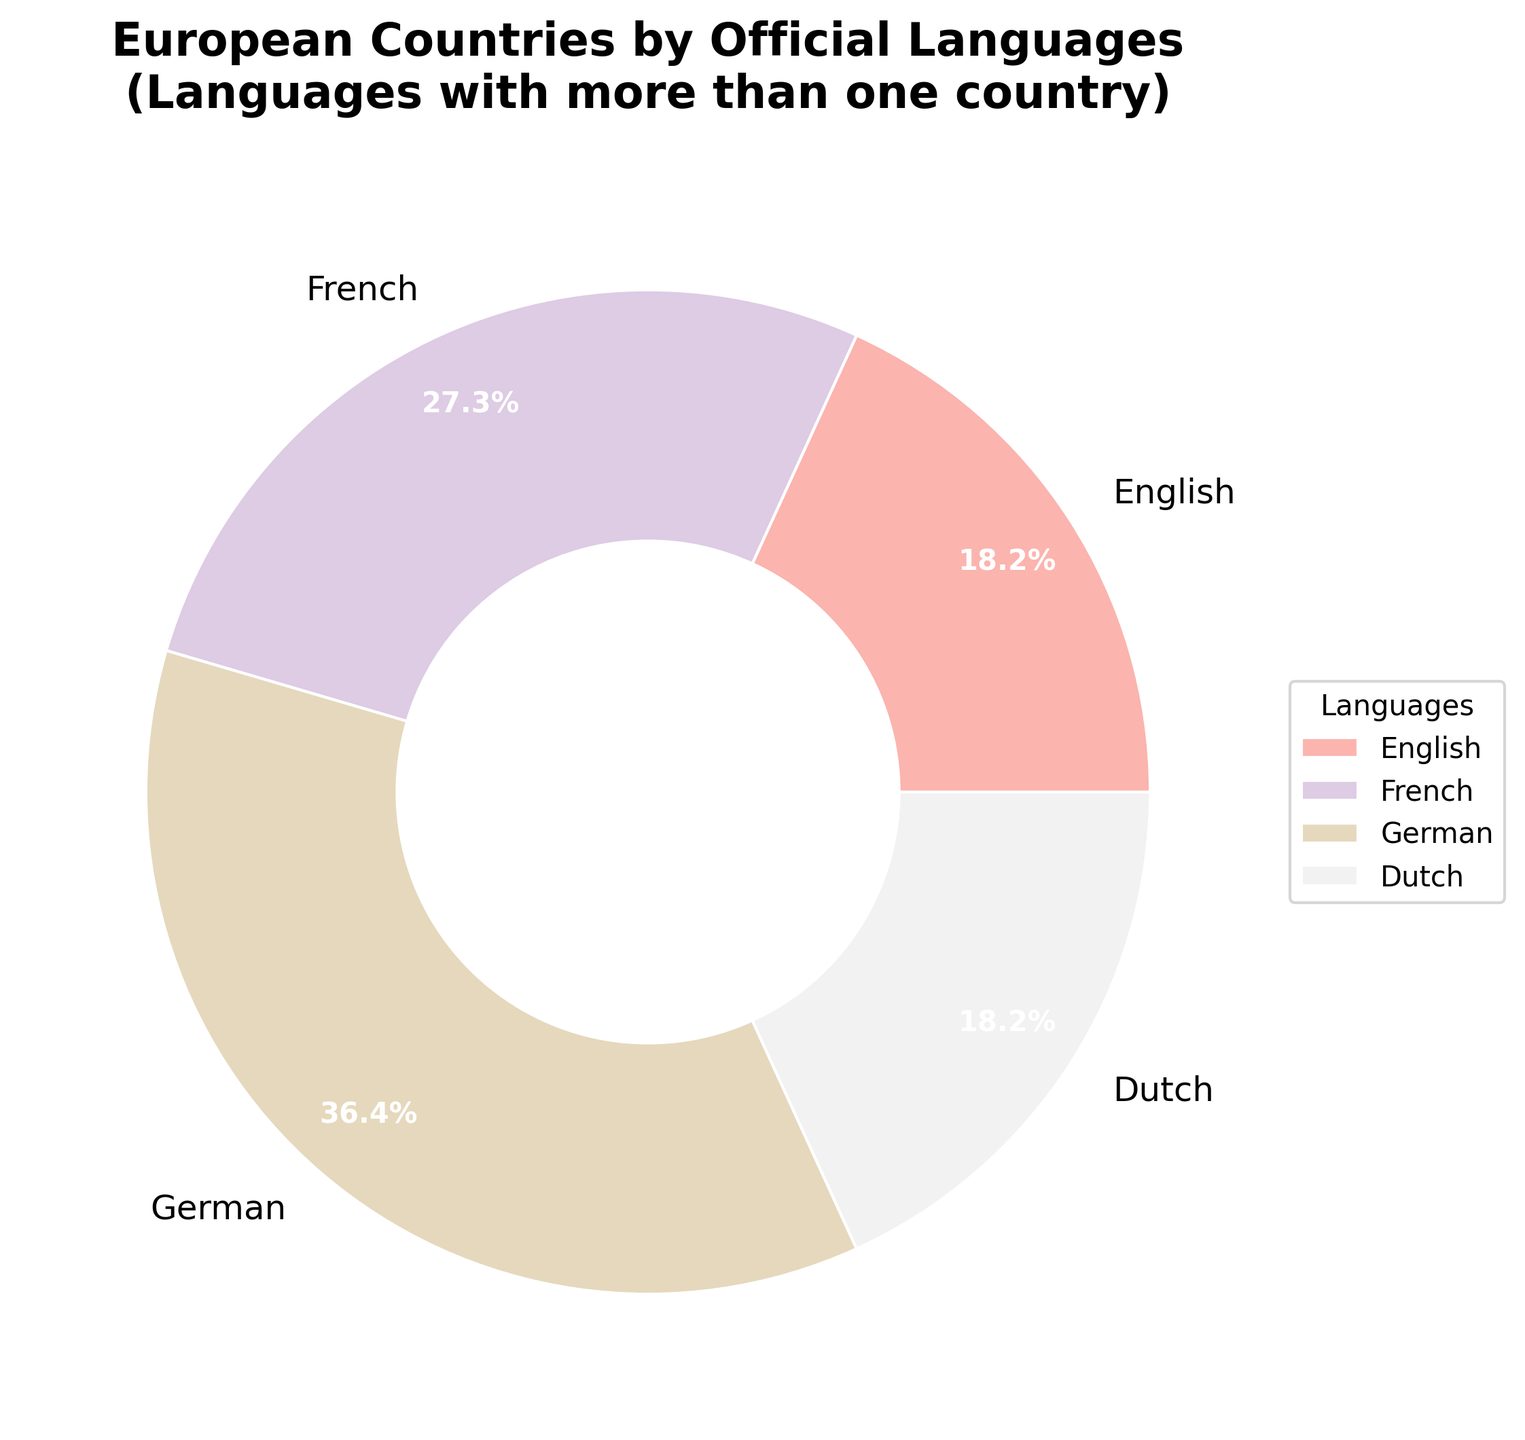Which language is the official language of the most countries? From the pie chart, German appears to account for the highest percentage. German is associated with 4 countries, which is more than any other language in the chart.
Answer: German How many languages are shared by more than one country? The pie chart displays sections with labels and percentages. Adding the sections that have more than one country, we see English (2), French (3), German (4), and Dutch (2), resulting in 4 languages.
Answer: 4 What percentage of the countries listed use French as an official language? From the pie chart, French is represented as 23.1%. This value directly indicates the percentage of countries that use French as an official language.
Answer: 23.1% Which languages tie for the fewest number of countries using them? The chart only includes languages shared by more than one country, but based on the data, other languages like Italian, Spanish, etc., which are used by only 1 country each, would not appear here.
Answer: Italian, Spanish, etc If you were to combine the percentages of countries that speak English and French, what would be the total percentage? From the pie chart, English accounts for 15.4% and French accounts for 23.1%. Adding these yields 15.4% + 23.1% = 38.5%.
Answer: 38.5% Is Dutch spoken in more or fewer countries than English? According to the pie chart, Dutch is spoken in fewer countries than English. Dutch is represented with 15.4%, while English also has 15.4%, but the number of countries for Dutch and English are both 2 each.
Answer: Fewer (equal number in this specific subset) Which section is represented with the color towards the bottom of the pie chart? The largest bottom wedge of the pie chart is colored in a particular shade and labeled German, indicating the section towards the bottom.
Answer: German Compare the combined total percentage of countries speaking German and French to that of the countries speaking English and Dutch. German is 30.8% and French is 23.1%, adding up to 53.9%. English is 15.4% and Dutch is also 15.4%. Adding these two gives 30.8%. Thus, 53.9% (German + French) is greater than 30.8% (English + Dutch).
Answer: German and French: 53.9%, English and Dutch: 30.8% Which languages are represented by the two largest sections in the pie chart? Observing the pie chart, the two largest sections are labeled German and French. German is the largest, followed by French.
Answer: German and French 